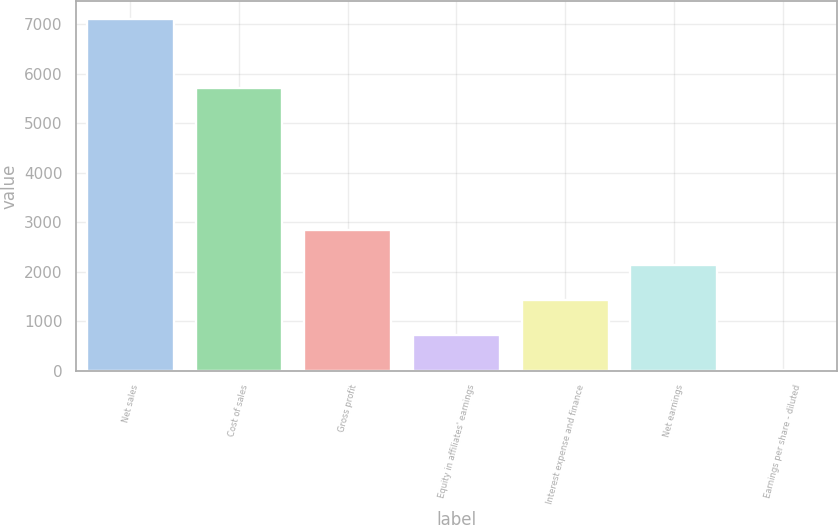Convert chart to OTSL. <chart><loc_0><loc_0><loc_500><loc_500><bar_chart><fcel>Net sales<fcel>Cost of sales<fcel>Gross profit<fcel>Equity in affiliates' earnings<fcel>Interest expense and finance<fcel>Net earnings<fcel>Earnings per share - diluted<nl><fcel>7114.7<fcel>5704.3<fcel>2848.56<fcel>715.48<fcel>1426.51<fcel>2137.53<fcel>4.45<nl></chart> 